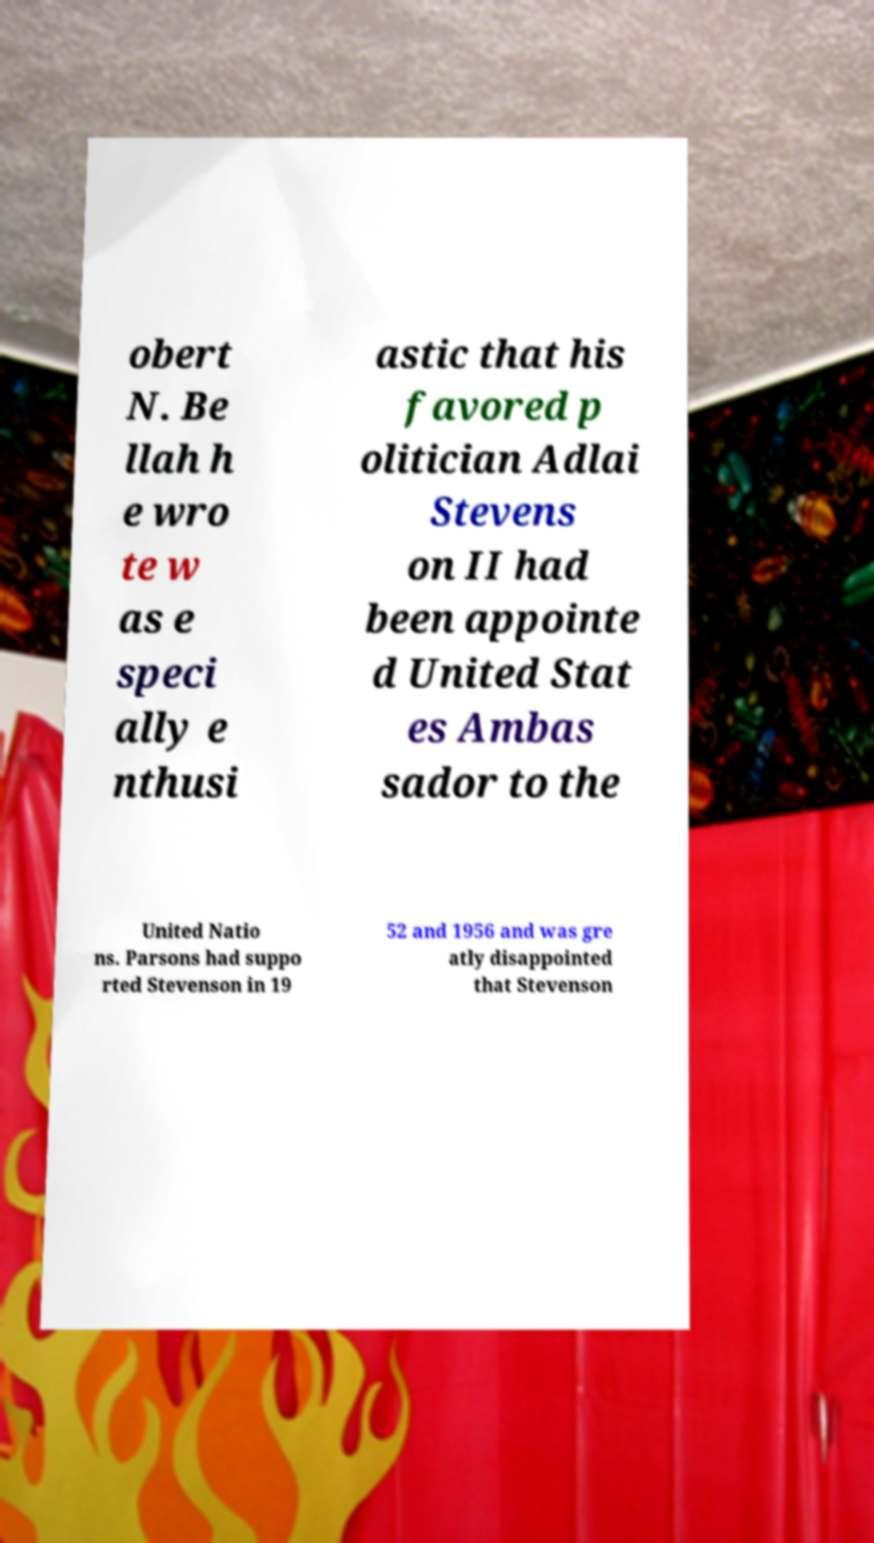Can you accurately transcribe the text from the provided image for me? obert N. Be llah h e wro te w as e speci ally e nthusi astic that his favored p olitician Adlai Stevens on II had been appointe d United Stat es Ambas sador to the United Natio ns. Parsons had suppo rted Stevenson in 19 52 and 1956 and was gre atly disappointed that Stevenson 